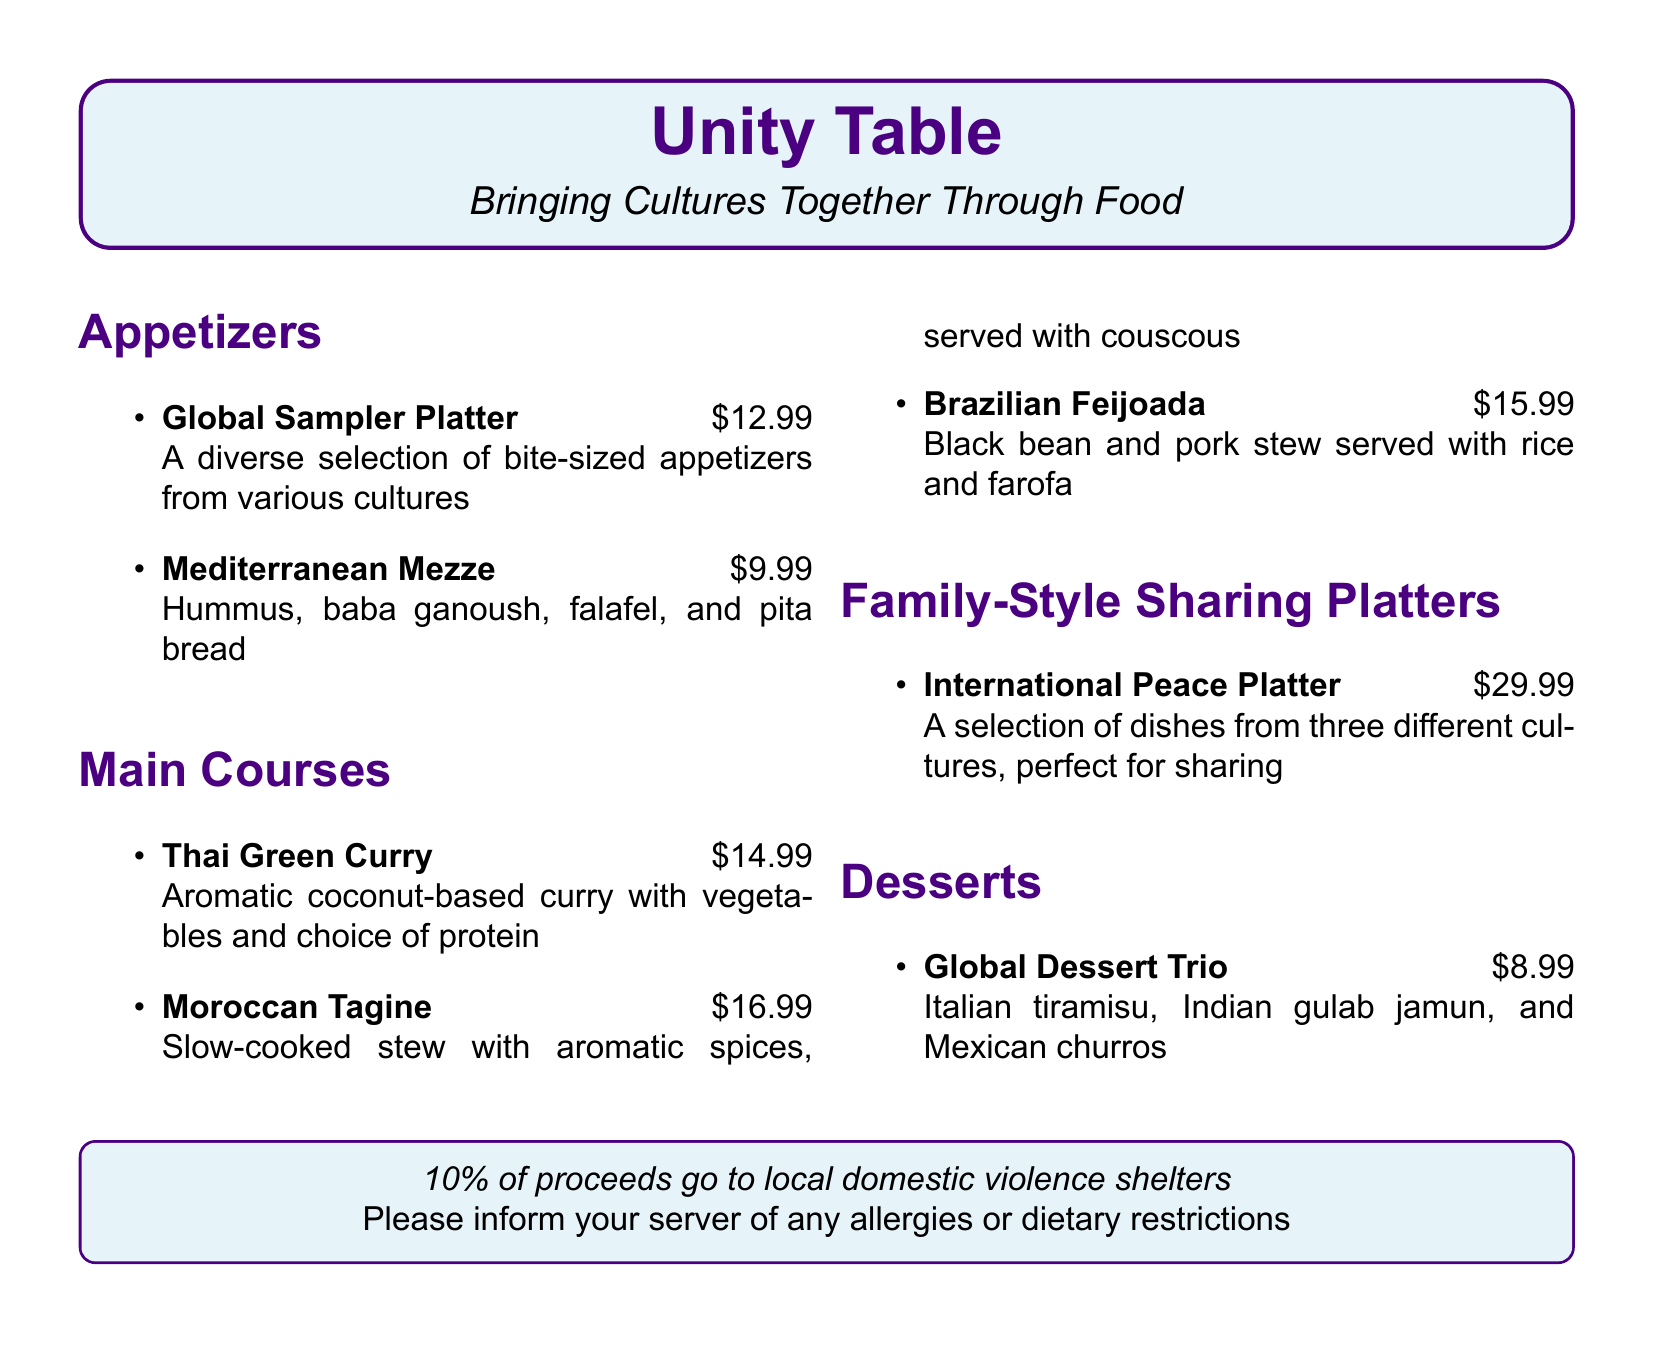What is the title of the menu? The title of the menu is prominently displayed in a box at the top of the document.
Answer: Unity Table How much does the Global Sampler Platter cost? The price for the Global Sampler Platter is listed under the appetizers section.
Answer: $12.99 What type of cuisine is the Thai Green Curry? The Thai Green Curry is categorized under the main courses section of the menu.
Answer: Thai What percentage of proceeds go to local domestic violence shelters? This information is stated in a box at the bottom of the document regarding proceeds from the menu.
Answer: 10% What is included in the Global Dessert Trio? The Global Dessert Trio consists of three different desserts listed under the desserts section.
Answer: Tiramisu, gulab jamun, churros How many different cultures are represented in the International Peace Platter? The description of the International Peace Platter notes that it features selections from three cultures.
Answer: Three What is served with the Moroccan Tagine? The Moroccan Tagine is served with an additional side mentioned in the main courses section.
Answer: Couscous What type of dish is the Brazilian Feijoada? The Brazilian Feijoada is classified within the main courses section of the menu.
Answer: Stew What style of dining is promoted with the Family-Style Sharing Platters? This section indicates that the dishes are intended for shared dining experiences.
Answer: Sharing 